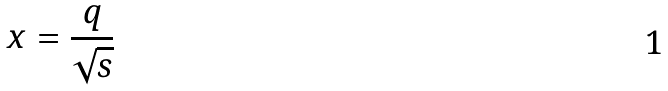Convert formula to latex. <formula><loc_0><loc_0><loc_500><loc_500>x = \frac { q } { \sqrt { s } }</formula> 